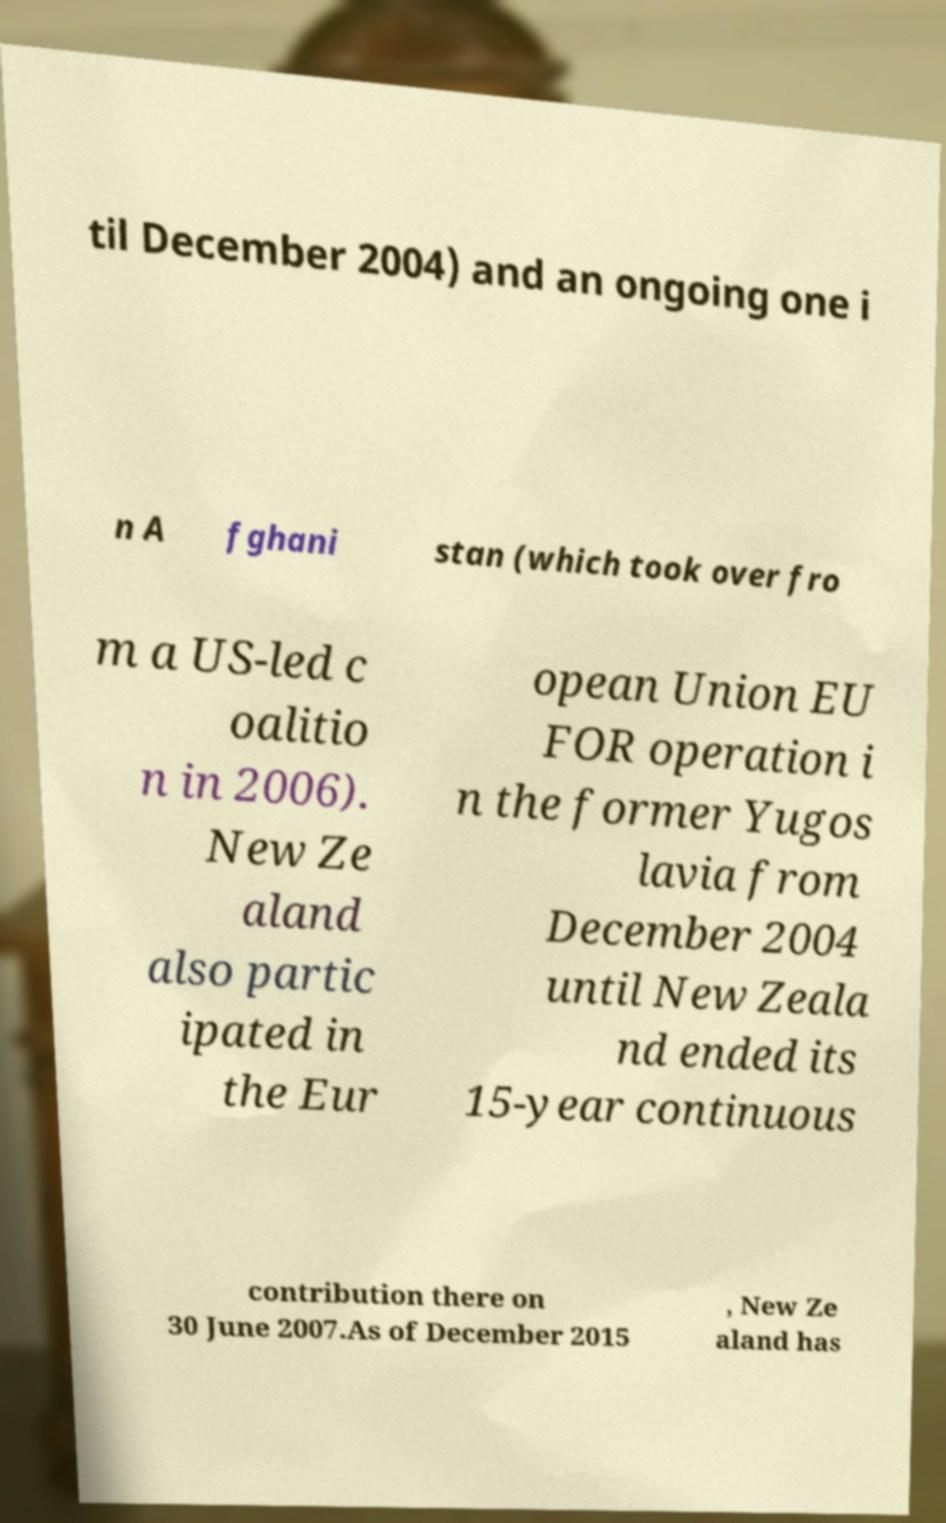There's text embedded in this image that I need extracted. Can you transcribe it verbatim? til December 2004) and an ongoing one i n A fghani stan (which took over fro m a US-led c oalitio n in 2006). New Ze aland also partic ipated in the Eur opean Union EU FOR operation i n the former Yugos lavia from December 2004 until New Zeala nd ended its 15-year continuous contribution there on 30 June 2007.As of December 2015 , New Ze aland has 